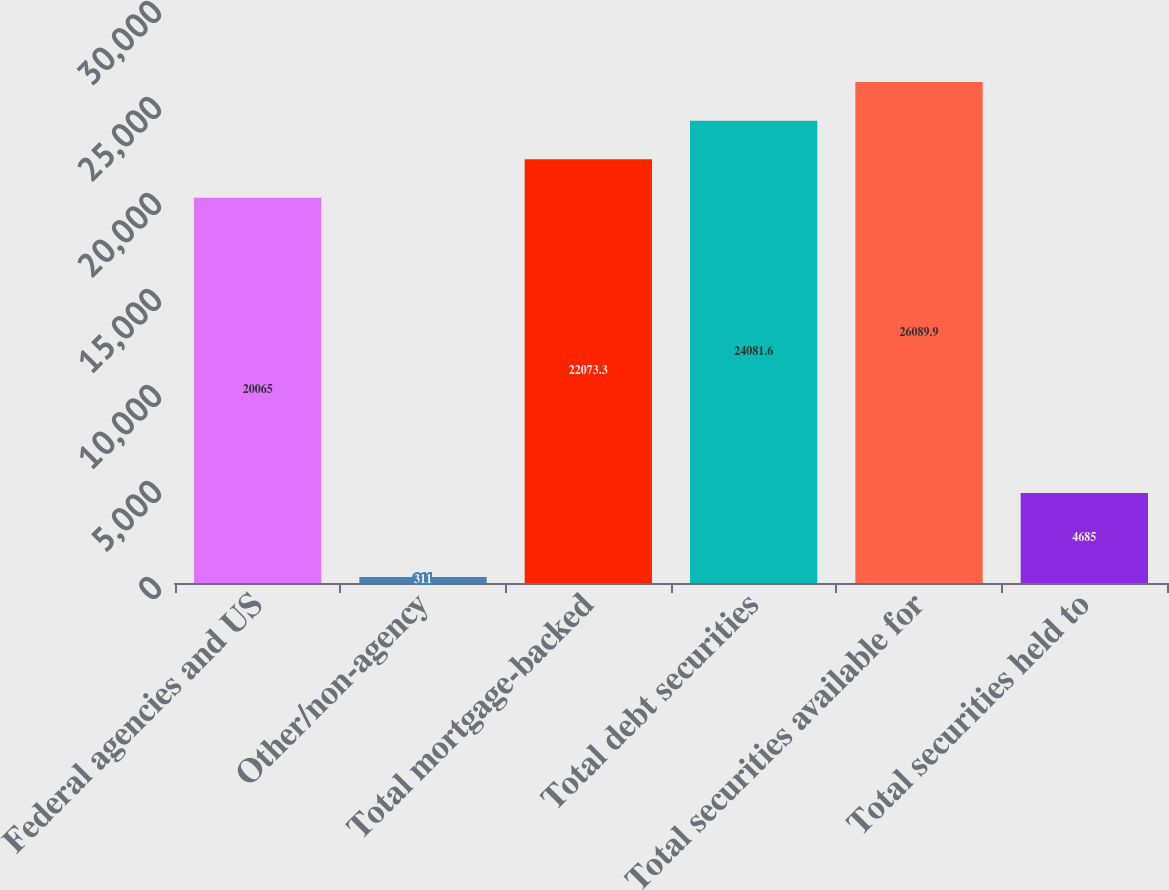<chart> <loc_0><loc_0><loc_500><loc_500><bar_chart><fcel>Federal agencies and US<fcel>Other/non-agency<fcel>Total mortgage-backed<fcel>Total debt securities<fcel>Total securities available for<fcel>Total securities held to<nl><fcel>20065<fcel>311<fcel>22073.3<fcel>24081.6<fcel>26089.9<fcel>4685<nl></chart> 